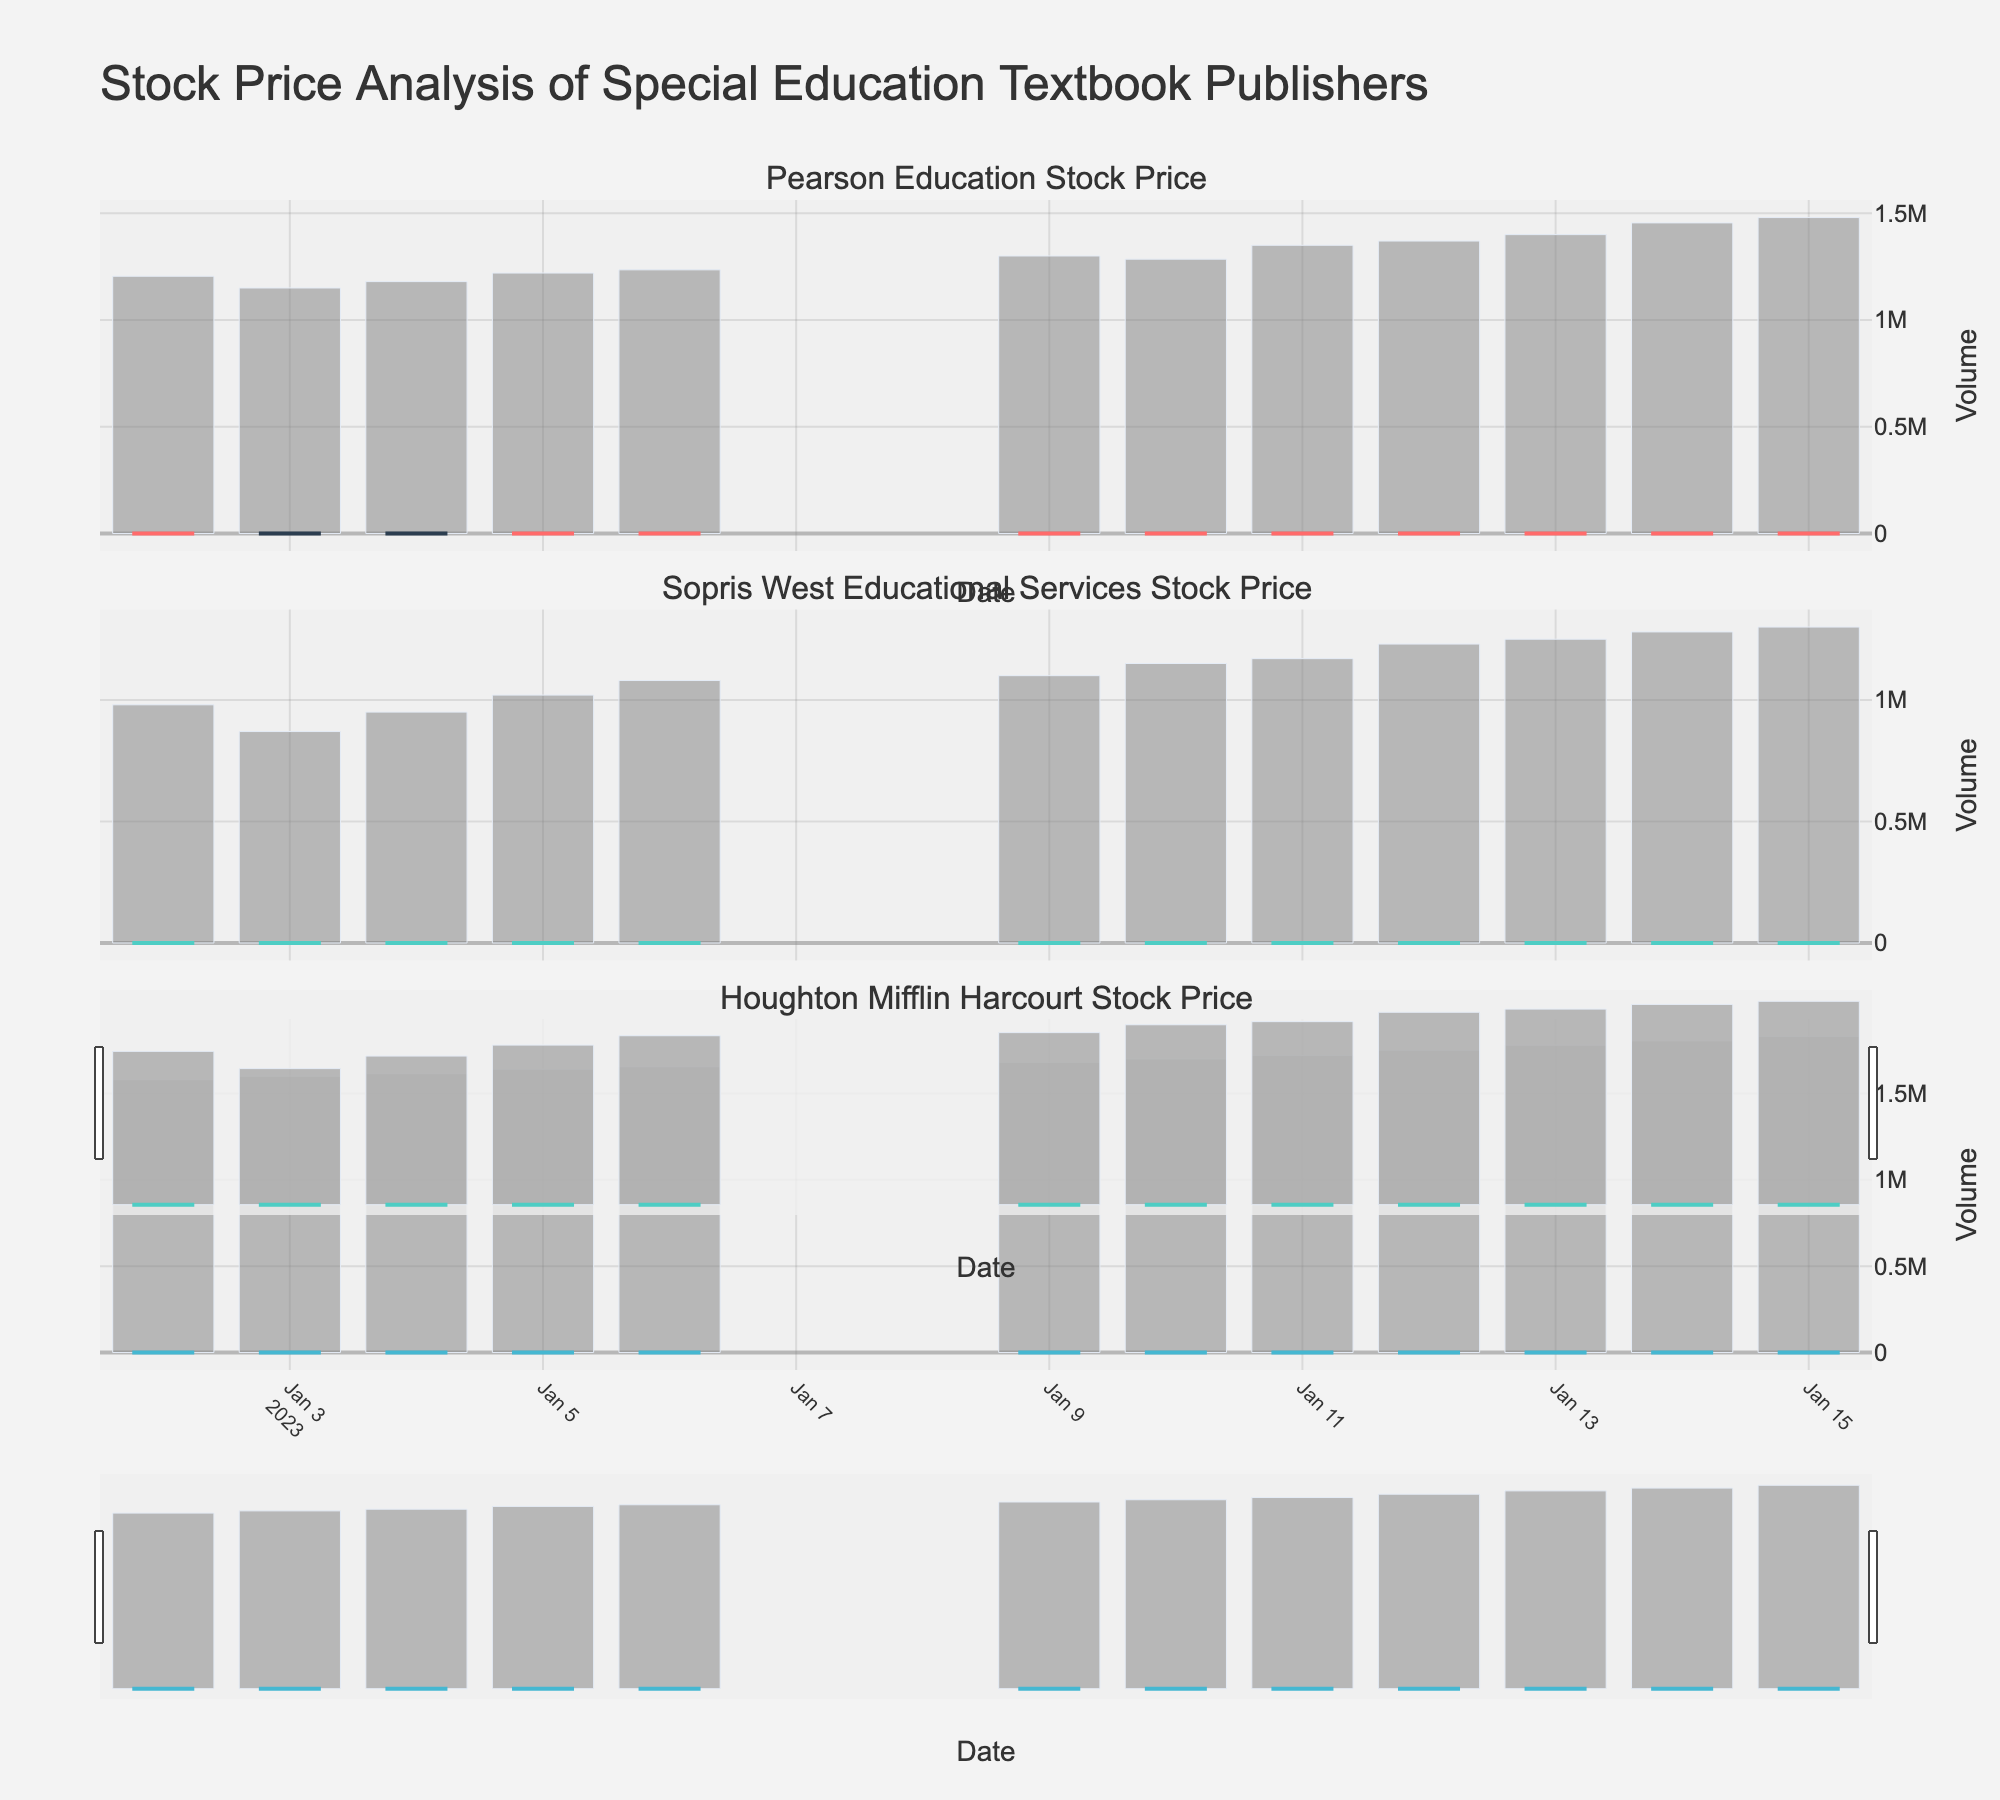What is the highest stock price of Houghton Mifflin Harcourt during the given period? Look at the candlestick plot for Houghton Mifflin Harcourt. Identify the highest "high" value recorded in the date range.
Answer: 93.5 How many publishers are shown in the figure? Observe the number of subplot titles, each representing a different publisher.
Answer: 3 What is the closing price of Pearson Education on January 4, 2023? Find the specific candlestick for Pearson Education on January 4, 2023, and note the closing price indicated on the candlestick's top or bottom edge.
Answer: 45.9 Which publisher had the greatest overall increase in stock price from January 2 to January 15, 2023? Calculate the difference between the closing prices on January 15 and January 2 for each publisher, then compare the values.
Answer: Sopris West Educational Services What is the median trading volume for Sopris West Educational Services? List all the trading volumes for Sopris West Educational Services for the given dates, order them, and determine the middle value.
Answer: 1100000 Which day had the highest trading volume for Pearson Education? Look at the bar chart for Pearson Education and identify the tallest bar, noting its corresponding date.
Answer: January 15, 2023 Did Houghton Mifflin Harcourt’s stock price ever decrease from its opening to closing price during the given period? Check each candlestick for Houghton Mifflin Harcourt to see if any have a higher opening price than closing price (filled candlestick).
Answer: Yes What is the average closing price of Pearson Education over the given period? Sum all closing prices for Pearson Education and divide by the number of trading days.
Answer: 48.2 During the given period, how often did Sopris West Educational Services' stock price close higher than it opened? Count the number of candlesticks for Sopris West Educational Services that have a higher closing price than opening price.
Answer: 9 Which publisher had the most stable stock price, indicated by the smallest range between high and low prices? Calculate the range (difference between high and low) for each publisher on each day and find the publisher with the smallest average range.
Answer: Pearson Education 